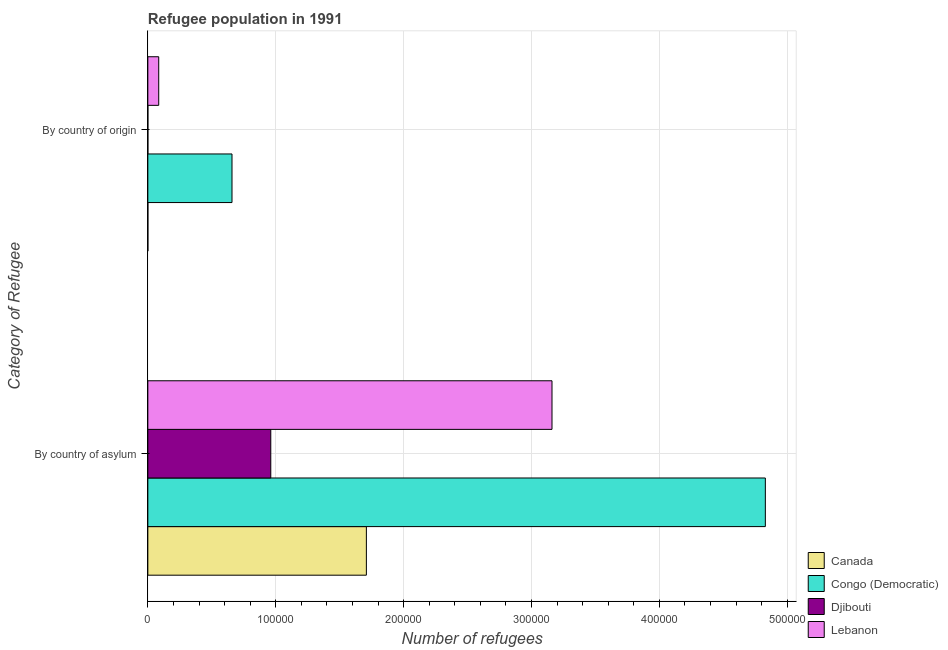How many groups of bars are there?
Provide a succinct answer. 2. How many bars are there on the 2nd tick from the bottom?
Offer a terse response. 4. What is the label of the 2nd group of bars from the top?
Offer a terse response. By country of asylum. What is the number of refugees by country of asylum in Djibouti?
Provide a short and direct response. 9.61e+04. Across all countries, what is the maximum number of refugees by country of origin?
Your answer should be compact. 6.58e+04. Across all countries, what is the minimum number of refugees by country of asylum?
Provide a succinct answer. 9.61e+04. In which country was the number of refugees by country of origin maximum?
Make the answer very short. Congo (Democratic). In which country was the number of refugees by country of origin minimum?
Your answer should be compact. Canada. What is the total number of refugees by country of origin in the graph?
Provide a succinct answer. 7.43e+04. What is the difference between the number of refugees by country of asylum in Djibouti and that in Canada?
Your answer should be compact. -7.48e+04. What is the difference between the number of refugees by country of origin in Congo (Democratic) and the number of refugees by country of asylum in Canada?
Ensure brevity in your answer.  -1.05e+05. What is the average number of refugees by country of origin per country?
Make the answer very short. 1.86e+04. What is the difference between the number of refugees by country of origin and number of refugees by country of asylum in Canada?
Keep it short and to the point. -1.71e+05. What is the ratio of the number of refugees by country of asylum in Congo (Democratic) to that in Djibouti?
Your answer should be compact. 5.02. What does the 3rd bar from the top in By country of asylum represents?
Provide a short and direct response. Congo (Democratic). What does the 3rd bar from the bottom in By country of asylum represents?
Keep it short and to the point. Djibouti. How many bars are there?
Provide a short and direct response. 8. How many countries are there in the graph?
Your response must be concise. 4. Are the values on the major ticks of X-axis written in scientific E-notation?
Make the answer very short. No. Does the graph contain any zero values?
Make the answer very short. No. How many legend labels are there?
Provide a short and direct response. 4. What is the title of the graph?
Offer a terse response. Refugee population in 1991. Does "Namibia" appear as one of the legend labels in the graph?
Keep it short and to the point. No. What is the label or title of the X-axis?
Your answer should be compact. Number of refugees. What is the label or title of the Y-axis?
Offer a terse response. Category of Refugee. What is the Number of refugees in Canada in By country of asylum?
Your answer should be very brief. 1.71e+05. What is the Number of refugees in Congo (Democratic) in By country of asylum?
Offer a terse response. 4.83e+05. What is the Number of refugees in Djibouti in By country of asylum?
Your answer should be very brief. 9.61e+04. What is the Number of refugees of Lebanon in By country of asylum?
Provide a short and direct response. 3.16e+05. What is the Number of refugees of Canada in By country of origin?
Your answer should be very brief. 4. What is the Number of refugees of Congo (Democratic) in By country of origin?
Offer a terse response. 6.58e+04. What is the Number of refugees in Lebanon in By country of origin?
Keep it short and to the point. 8501. Across all Category of Refugee, what is the maximum Number of refugees of Canada?
Make the answer very short. 1.71e+05. Across all Category of Refugee, what is the maximum Number of refugees in Congo (Democratic)?
Provide a short and direct response. 4.83e+05. Across all Category of Refugee, what is the maximum Number of refugees in Djibouti?
Provide a short and direct response. 9.61e+04. Across all Category of Refugee, what is the maximum Number of refugees of Lebanon?
Offer a very short reply. 3.16e+05. Across all Category of Refugee, what is the minimum Number of refugees of Canada?
Offer a terse response. 4. Across all Category of Refugee, what is the minimum Number of refugees in Congo (Democratic)?
Provide a succinct answer. 6.58e+04. Across all Category of Refugee, what is the minimum Number of refugees in Djibouti?
Your answer should be compact. 10. Across all Category of Refugee, what is the minimum Number of refugees of Lebanon?
Offer a terse response. 8501. What is the total Number of refugees in Canada in the graph?
Offer a terse response. 1.71e+05. What is the total Number of refugees of Congo (Democratic) in the graph?
Your response must be concise. 5.49e+05. What is the total Number of refugees in Djibouti in the graph?
Your answer should be compact. 9.62e+04. What is the total Number of refugees of Lebanon in the graph?
Offer a terse response. 3.25e+05. What is the difference between the Number of refugees of Canada in By country of asylum and that in By country of origin?
Offer a very short reply. 1.71e+05. What is the difference between the Number of refugees in Congo (Democratic) in By country of asylum and that in By country of origin?
Your answer should be very brief. 4.17e+05. What is the difference between the Number of refugees in Djibouti in By country of asylum and that in By country of origin?
Make the answer very short. 9.61e+04. What is the difference between the Number of refugees of Lebanon in By country of asylum and that in By country of origin?
Your answer should be compact. 3.08e+05. What is the difference between the Number of refugees in Canada in By country of asylum and the Number of refugees in Congo (Democratic) in By country of origin?
Offer a very short reply. 1.05e+05. What is the difference between the Number of refugees in Canada in By country of asylum and the Number of refugees in Djibouti in By country of origin?
Keep it short and to the point. 1.71e+05. What is the difference between the Number of refugees of Canada in By country of asylum and the Number of refugees of Lebanon in By country of origin?
Your answer should be very brief. 1.62e+05. What is the difference between the Number of refugees of Congo (Democratic) in By country of asylum and the Number of refugees of Djibouti in By country of origin?
Your answer should be compact. 4.83e+05. What is the difference between the Number of refugees of Congo (Democratic) in By country of asylum and the Number of refugees of Lebanon in By country of origin?
Your answer should be very brief. 4.74e+05. What is the difference between the Number of refugees in Djibouti in By country of asylum and the Number of refugees in Lebanon in By country of origin?
Offer a very short reply. 8.76e+04. What is the average Number of refugees of Canada per Category of Refugee?
Your answer should be very brief. 8.55e+04. What is the average Number of refugees of Congo (Democratic) per Category of Refugee?
Make the answer very short. 2.74e+05. What is the average Number of refugees of Djibouti per Category of Refugee?
Your answer should be compact. 4.81e+04. What is the average Number of refugees in Lebanon per Category of Refugee?
Your answer should be very brief. 1.62e+05. What is the difference between the Number of refugees in Canada and Number of refugees in Congo (Democratic) in By country of asylum?
Offer a terse response. -3.12e+05. What is the difference between the Number of refugees in Canada and Number of refugees in Djibouti in By country of asylum?
Make the answer very short. 7.48e+04. What is the difference between the Number of refugees of Canada and Number of refugees of Lebanon in By country of asylum?
Give a very brief answer. -1.45e+05. What is the difference between the Number of refugees of Congo (Democratic) and Number of refugees of Djibouti in By country of asylum?
Give a very brief answer. 3.87e+05. What is the difference between the Number of refugees in Congo (Democratic) and Number of refugees in Lebanon in By country of asylum?
Provide a succinct answer. 1.67e+05. What is the difference between the Number of refugees of Djibouti and Number of refugees of Lebanon in By country of asylum?
Your response must be concise. -2.20e+05. What is the difference between the Number of refugees in Canada and Number of refugees in Congo (Democratic) in By country of origin?
Offer a terse response. -6.58e+04. What is the difference between the Number of refugees in Canada and Number of refugees in Djibouti in By country of origin?
Make the answer very short. -6. What is the difference between the Number of refugees of Canada and Number of refugees of Lebanon in By country of origin?
Offer a very short reply. -8497. What is the difference between the Number of refugees in Congo (Democratic) and Number of refugees in Djibouti in By country of origin?
Make the answer very short. 6.58e+04. What is the difference between the Number of refugees in Congo (Democratic) and Number of refugees in Lebanon in By country of origin?
Give a very brief answer. 5.73e+04. What is the difference between the Number of refugees in Djibouti and Number of refugees in Lebanon in By country of origin?
Your response must be concise. -8491. What is the ratio of the Number of refugees of Canada in By country of asylum to that in By country of origin?
Provide a succinct answer. 4.27e+04. What is the ratio of the Number of refugees in Congo (Democratic) in By country of asylum to that in By country of origin?
Your response must be concise. 7.34. What is the ratio of the Number of refugees of Djibouti in By country of asylum to that in By country of origin?
Your answer should be compact. 9614.4. What is the ratio of the Number of refugees in Lebanon in By country of asylum to that in By country of origin?
Provide a succinct answer. 37.18. What is the difference between the highest and the second highest Number of refugees in Canada?
Ensure brevity in your answer.  1.71e+05. What is the difference between the highest and the second highest Number of refugees of Congo (Democratic)?
Keep it short and to the point. 4.17e+05. What is the difference between the highest and the second highest Number of refugees of Djibouti?
Provide a short and direct response. 9.61e+04. What is the difference between the highest and the second highest Number of refugees in Lebanon?
Offer a terse response. 3.08e+05. What is the difference between the highest and the lowest Number of refugees in Canada?
Make the answer very short. 1.71e+05. What is the difference between the highest and the lowest Number of refugees of Congo (Democratic)?
Give a very brief answer. 4.17e+05. What is the difference between the highest and the lowest Number of refugees in Djibouti?
Your response must be concise. 9.61e+04. What is the difference between the highest and the lowest Number of refugees in Lebanon?
Provide a succinct answer. 3.08e+05. 